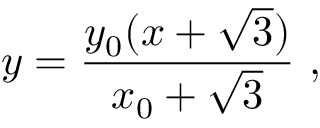<formula> <loc_0><loc_0><loc_500><loc_500>y = \frac { y _ { 0 } ( x + \sqrt { 3 } ) } { x _ { 0 } + \sqrt { 3 } } \ ,</formula> 